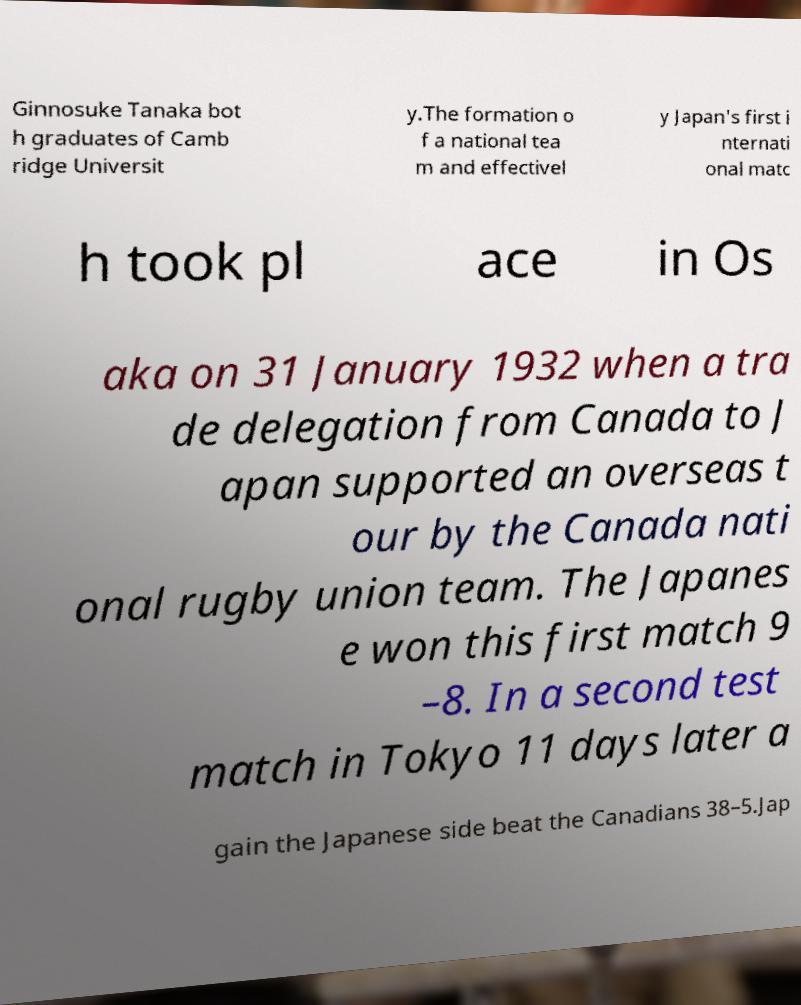I need the written content from this picture converted into text. Can you do that? Ginnosuke Tanaka bot h graduates of Camb ridge Universit y.The formation o f a national tea m and effectivel y Japan's first i nternati onal matc h took pl ace in Os aka on 31 January 1932 when a tra de delegation from Canada to J apan supported an overseas t our by the Canada nati onal rugby union team. The Japanes e won this first match 9 –8. In a second test match in Tokyo 11 days later a gain the Japanese side beat the Canadians 38–5.Jap 